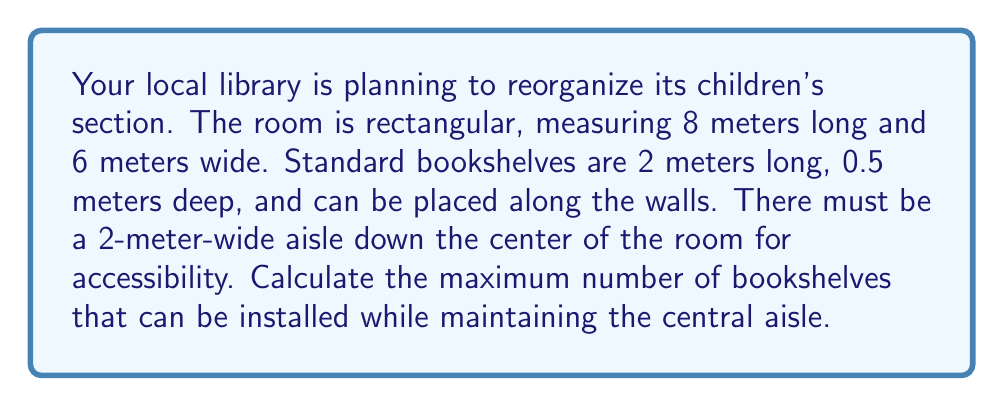Give your solution to this math problem. Let's approach this step-by-step:

1) First, we need to calculate the available wall space for bookshelves:
   - Total perimeter = $2(8 + 6) = 28$ meters
   - However, we need to subtract the space for the central aisle:
     $28 - 4 = 24$ meters (subtracting 2 meters from each short wall)

2) Now, we need to determine how many 2-meter bookshelves can fit in this 24-meter space:
   $$ \text{Number of bookshelves} = \left\lfloor\frac{24}{2}\right\rfloor = 12 $$
   We use the floor function because we can't have a fraction of a bookshelf.

3) We need to check if there's enough floor space for these bookshelves:
   - Room area = $8 \times 6 = 48$ sq meters
   - Aisle area = $8 \times 2 = 16$ sq meters
   - Remaining area = $48 - 16 = 32$ sq meters

4) Area taken by bookshelves:
   $12 \times 2 \times 0.5 = 12$ sq meters

5) Since 12 sq meters < 32 sq meters, there is enough floor space.

Therefore, the maximum number of bookshelves that can be installed is 12.
Answer: 12 bookshelves 